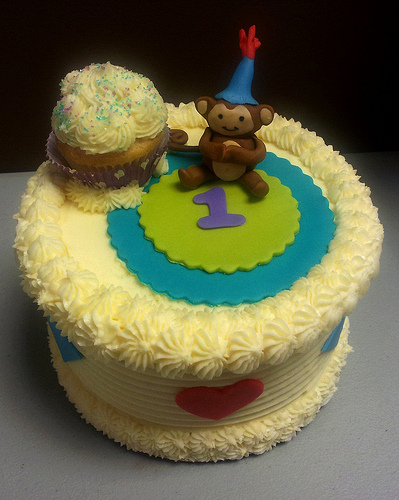<image>
Is there a monkey next to the cake? No. The monkey is not positioned next to the cake. They are located in different areas of the scene. 